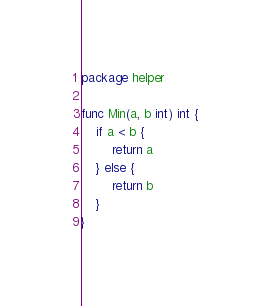<code> <loc_0><loc_0><loc_500><loc_500><_Go_>package helper

func Min(a, b int) int {
	if a < b {
		return a
	} else {
		return b
	}
}
</code> 